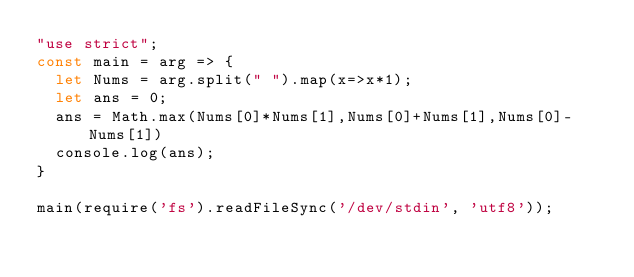<code> <loc_0><loc_0><loc_500><loc_500><_JavaScript_>"use strict";
const main = arg => {
  let Nums = arg.split(" ").map(x=>x*1);
  let ans = 0;
  ans = Math.max(Nums[0]*Nums[1],Nums[0]+Nums[1],Nums[0]-Nums[1])
  console.log(ans);
}

main(require('fs').readFileSync('/dev/stdin', 'utf8'));
</code> 